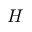Convert formula to latex. <formula><loc_0><loc_0><loc_500><loc_500>H</formula> 